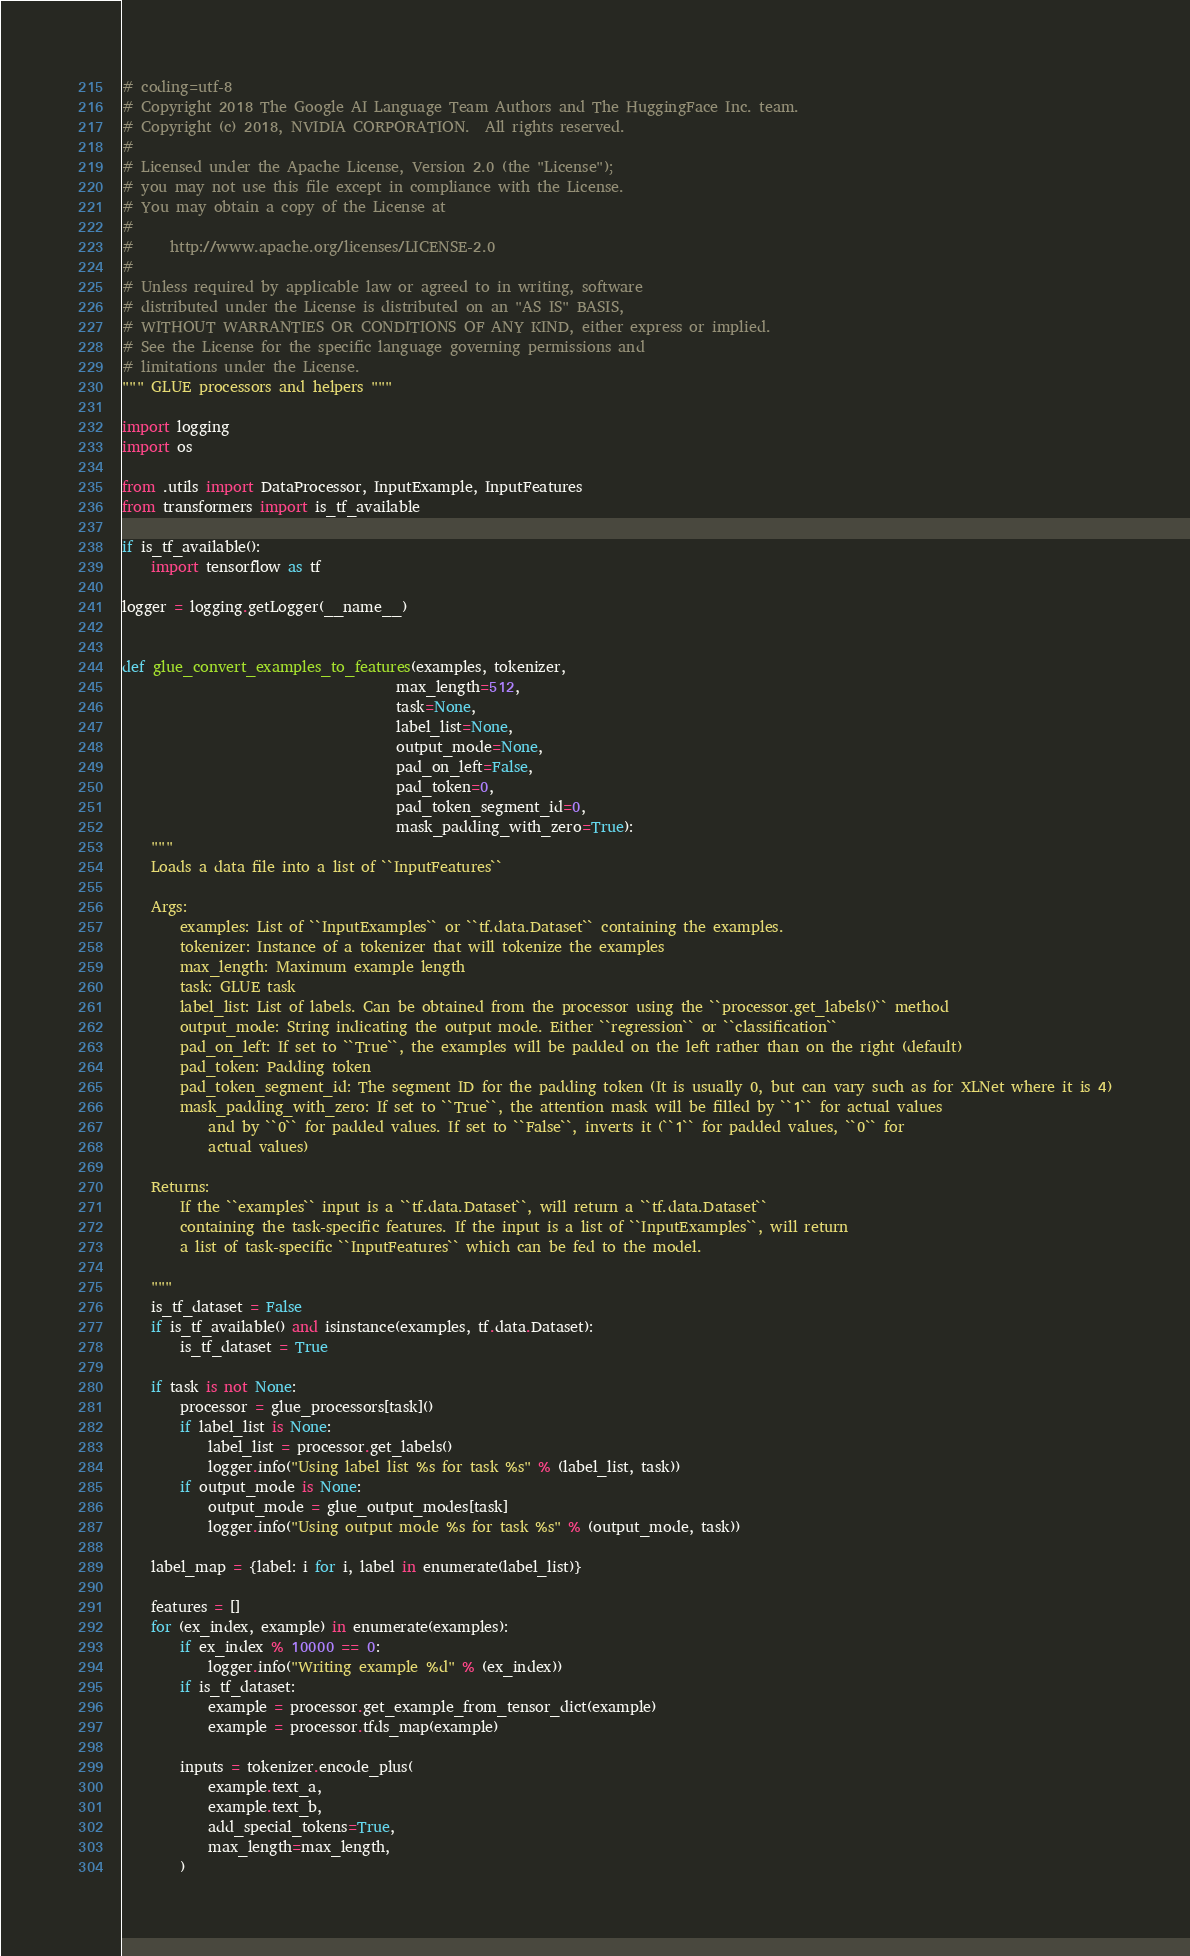Convert code to text. <code><loc_0><loc_0><loc_500><loc_500><_Python_># coding=utf-8
# Copyright 2018 The Google AI Language Team Authors and The HuggingFace Inc. team.
# Copyright (c) 2018, NVIDIA CORPORATION.  All rights reserved.
#
# Licensed under the Apache License, Version 2.0 (the "License");
# you may not use this file except in compliance with the License.
# You may obtain a copy of the License at
#
#     http://www.apache.org/licenses/LICENSE-2.0
#
# Unless required by applicable law or agreed to in writing, software
# distributed under the License is distributed on an "AS IS" BASIS,
# WITHOUT WARRANTIES OR CONDITIONS OF ANY KIND, either express or implied.
# See the License for the specific language governing permissions and
# limitations under the License.
""" GLUE processors and helpers """

import logging
import os

from .utils import DataProcessor, InputExample, InputFeatures
from transformers import is_tf_available

if is_tf_available():
    import tensorflow as tf

logger = logging.getLogger(__name__)


def glue_convert_examples_to_features(examples, tokenizer,
                                      max_length=512,
                                      task=None,
                                      label_list=None,
                                      output_mode=None,
                                      pad_on_left=False,
                                      pad_token=0,
                                      pad_token_segment_id=0,
                                      mask_padding_with_zero=True):
    """
    Loads a data file into a list of ``InputFeatures``

    Args:
        examples: List of ``InputExamples`` or ``tf.data.Dataset`` containing the examples.
        tokenizer: Instance of a tokenizer that will tokenize the examples
        max_length: Maximum example length
        task: GLUE task
        label_list: List of labels. Can be obtained from the processor using the ``processor.get_labels()`` method
        output_mode: String indicating the output mode. Either ``regression`` or ``classification``
        pad_on_left: If set to ``True``, the examples will be padded on the left rather than on the right (default)
        pad_token: Padding token
        pad_token_segment_id: The segment ID for the padding token (It is usually 0, but can vary such as for XLNet where it is 4)
        mask_padding_with_zero: If set to ``True``, the attention mask will be filled by ``1`` for actual values
            and by ``0`` for padded values. If set to ``False``, inverts it (``1`` for padded values, ``0`` for
            actual values)

    Returns:
        If the ``examples`` input is a ``tf.data.Dataset``, will return a ``tf.data.Dataset``
        containing the task-specific features. If the input is a list of ``InputExamples``, will return
        a list of task-specific ``InputFeatures`` which can be fed to the model.

    """
    is_tf_dataset = False
    if is_tf_available() and isinstance(examples, tf.data.Dataset):
        is_tf_dataset = True

    if task is not None:
        processor = glue_processors[task]()
        if label_list is None:
            label_list = processor.get_labels()
            logger.info("Using label list %s for task %s" % (label_list, task))
        if output_mode is None:
            output_mode = glue_output_modes[task]
            logger.info("Using output mode %s for task %s" % (output_mode, task))

    label_map = {label: i for i, label in enumerate(label_list)}

    features = []
    for (ex_index, example) in enumerate(examples):
        if ex_index % 10000 == 0:
            logger.info("Writing example %d" % (ex_index))
        if is_tf_dataset:
            example = processor.get_example_from_tensor_dict(example)
            example = processor.tfds_map(example)

        inputs = tokenizer.encode_plus(
            example.text_a,
            example.text_b,
            add_special_tokens=True,
            max_length=max_length,
        )</code> 